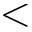Convert formula to latex. <formula><loc_0><loc_0><loc_500><loc_500><</formula> 